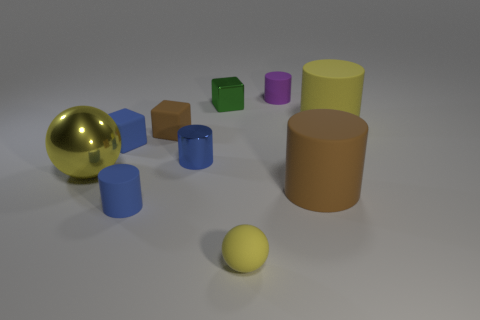Subtract all brown cylinders. How many cylinders are left? 4 Subtract all blue matte cylinders. How many cylinders are left? 4 Subtract all red cylinders. Subtract all gray cubes. How many cylinders are left? 5 Subtract all cubes. How many objects are left? 7 Add 1 yellow objects. How many yellow objects are left? 4 Add 2 yellow metallic cylinders. How many yellow metallic cylinders exist? 2 Subtract 0 red cylinders. How many objects are left? 10 Subtract all brown things. Subtract all small yellow objects. How many objects are left? 7 